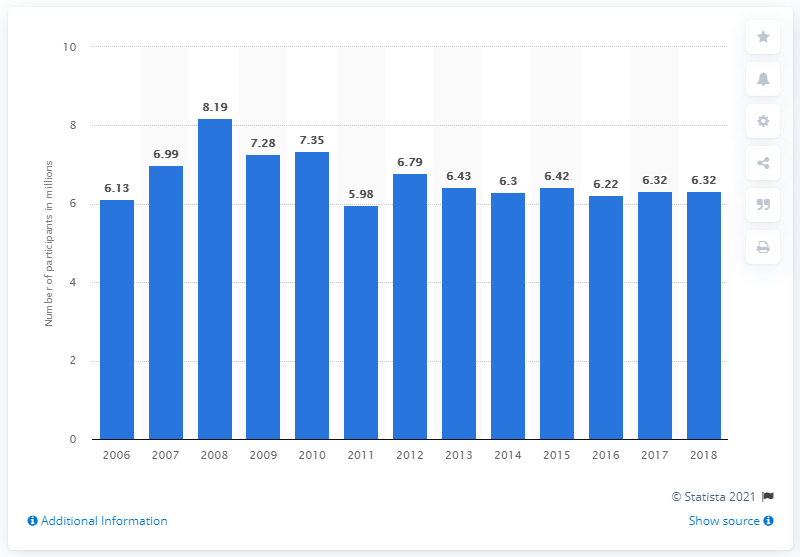Specify some key components in this picture. In 2018, the total number of court volleyball participants was 6,320. 